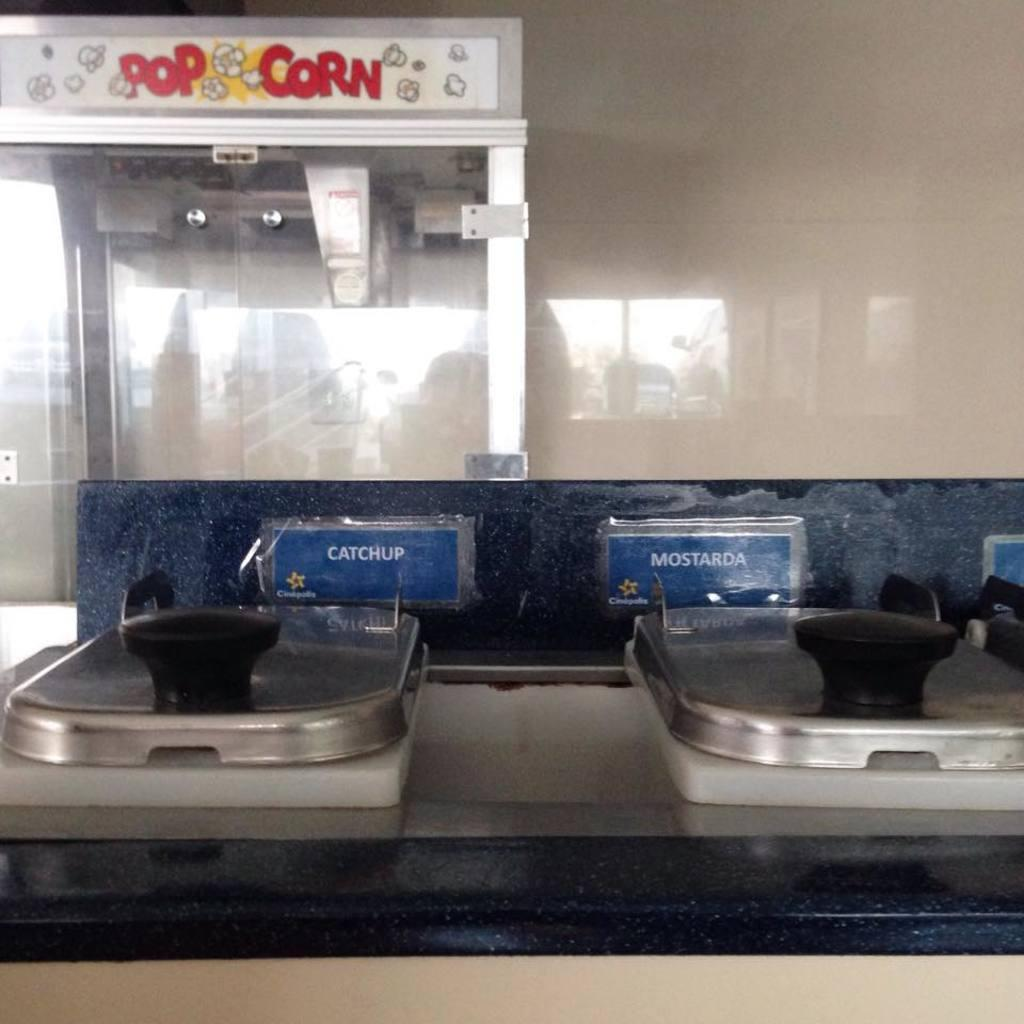<image>
Provide a brief description of the given image. A condiment station that includes catchup and mostarda with a pop corn machine in the background. 